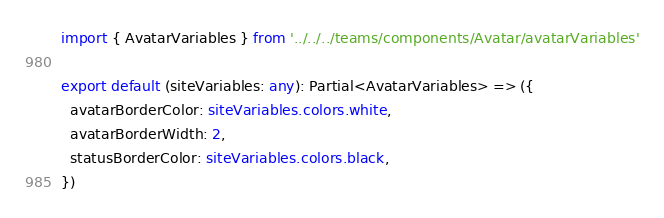<code> <loc_0><loc_0><loc_500><loc_500><_TypeScript_>import { AvatarVariables } from '../../../teams/components/Avatar/avatarVariables'

export default (siteVariables: any): Partial<AvatarVariables> => ({
  avatarBorderColor: siteVariables.colors.white,
  avatarBorderWidth: 2,
  statusBorderColor: siteVariables.colors.black,
})
</code> 